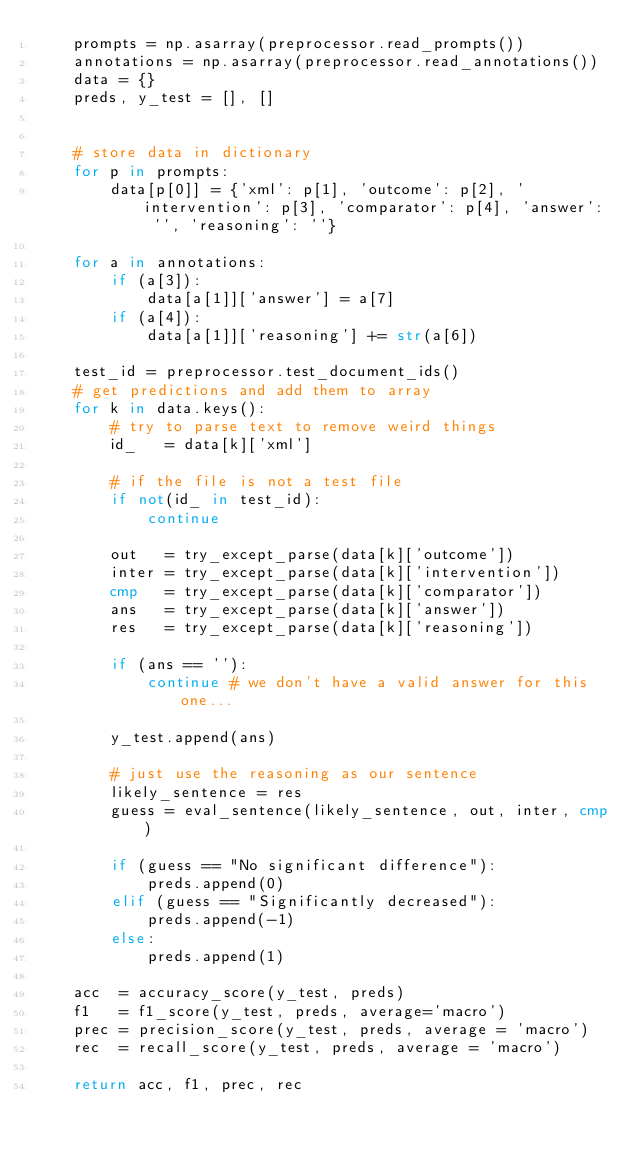Convert code to text. <code><loc_0><loc_0><loc_500><loc_500><_Python_>    prompts = np.asarray(preprocessor.read_prompts())
    annotations = np.asarray(preprocessor.read_annotations())
    data = {}
    preds, y_test = [], []

    
    # store data in dictionary
    for p in prompts:
        data[p[0]] = {'xml': p[1], 'outcome': p[2], 'intervention': p[3], 'comparator': p[4], 'answer': '', 'reasoning': ''}
        
    for a in annotations:
        if (a[3]):
            data[a[1]]['answer'] = a[7]
        if (a[4]):
            data[a[1]]['reasoning'] += str(a[6])
       
    test_id = preprocessor.test_document_ids()
    # get predictions and add them to array
    for k in data.keys():
        # try to parse text to remove weird things
        id_   = data[k]['xml']
        
        # if the file is not a test file
        if not(id_ in test_id):
            continue 
        
        out   = try_except_parse(data[k]['outcome'])
        inter = try_except_parse(data[k]['intervention'])
        cmp   = try_except_parse(data[k]['comparator'])
        ans   = try_except_parse(data[k]['answer'])
        res   = try_except_parse(data[k]['reasoning'])
        
        if (ans == ''):
            continue # we don't have a valid answer for this one... 
            
        y_test.append(ans)

        # just use the reasoning as our sentence        
        likely_sentence = res
        guess = eval_sentence(likely_sentence, out, inter, cmp)
        
        if (guess == "No significant difference"):
            preds.append(0)
        elif (guess == "Significantly decreased"):
            preds.append(-1)
        else:
            preds.append(1)
         
    acc  = accuracy_score(y_test, preds)
    f1   = f1_score(y_test, preds, average='macro')
    prec = precision_score(y_test, preds, average = 'macro')
    rec  = recall_score(y_test, preds, average = 'macro')
        
    return acc, f1, prec, rec
</code> 